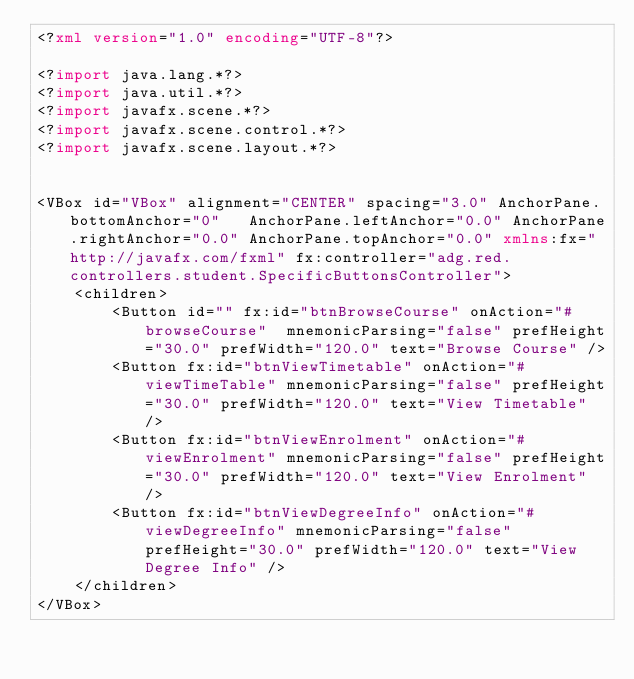<code> <loc_0><loc_0><loc_500><loc_500><_XML_><?xml version="1.0" encoding="UTF-8"?>

<?import java.lang.*?>
<?import java.util.*?>
<?import javafx.scene.*?>
<?import javafx.scene.control.*?>
<?import javafx.scene.layout.*?>


<VBox id="VBox" alignment="CENTER" spacing="3.0" AnchorPane.bottomAnchor="0"   AnchorPane.leftAnchor="0.0" AnchorPane.rightAnchor="0.0" AnchorPane.topAnchor="0.0" xmlns:fx="http://javafx.com/fxml" fx:controller="adg.red.controllers.student.SpecificButtonsController">
    <children>
        <Button id="" fx:id="btnBrowseCourse" onAction="#browseCourse"  mnemonicParsing="false" prefHeight="30.0" prefWidth="120.0" text="Browse Course" />
        <Button fx:id="btnViewTimetable" onAction="#viewTimeTable" mnemonicParsing="false" prefHeight="30.0" prefWidth="120.0" text="View Timetable" />
        <Button fx:id="btnViewEnrolment" onAction="#viewEnrolment" mnemonicParsing="false" prefHeight="30.0" prefWidth="120.0" text="View Enrolment" />
        <Button fx:id="btnViewDegreeInfo" onAction="#viewDegreeInfo" mnemonicParsing="false" prefHeight="30.0" prefWidth="120.0" text="View Degree Info" />
    </children>
</VBox>

</code> 